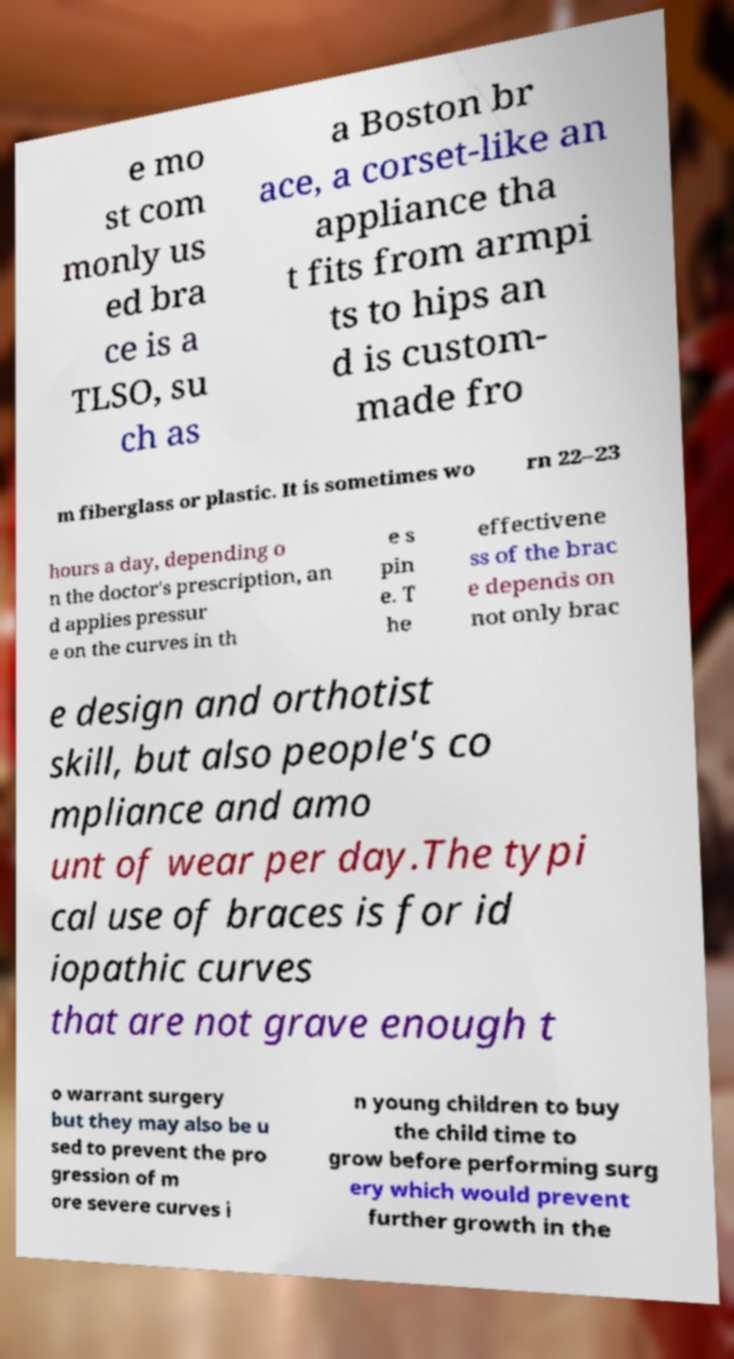There's text embedded in this image that I need extracted. Can you transcribe it verbatim? e mo st com monly us ed bra ce is a TLSO, su ch as a Boston br ace, a corset-like an appliance tha t fits from armpi ts to hips an d is custom- made fro m fiberglass or plastic. It is sometimes wo rn 22–23 hours a day, depending o n the doctor's prescription, an d applies pressur e on the curves in th e s pin e. T he effectivene ss of the brac e depends on not only brac e design and orthotist skill, but also people's co mpliance and amo unt of wear per day.The typi cal use of braces is for id iopathic curves that are not grave enough t o warrant surgery but they may also be u sed to prevent the pro gression of m ore severe curves i n young children to buy the child time to grow before performing surg ery which would prevent further growth in the 